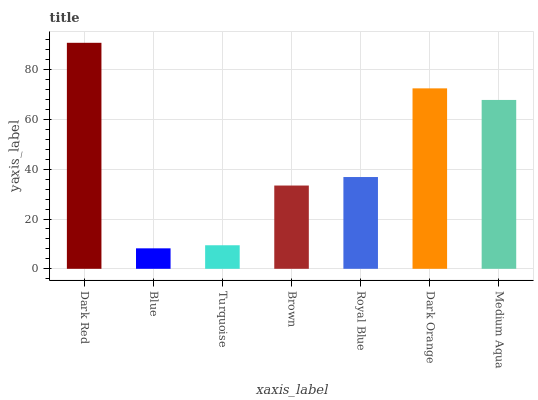Is Blue the minimum?
Answer yes or no. Yes. Is Dark Red the maximum?
Answer yes or no. Yes. Is Turquoise the minimum?
Answer yes or no. No. Is Turquoise the maximum?
Answer yes or no. No. Is Turquoise greater than Blue?
Answer yes or no. Yes. Is Blue less than Turquoise?
Answer yes or no. Yes. Is Blue greater than Turquoise?
Answer yes or no. No. Is Turquoise less than Blue?
Answer yes or no. No. Is Royal Blue the high median?
Answer yes or no. Yes. Is Royal Blue the low median?
Answer yes or no. Yes. Is Turquoise the high median?
Answer yes or no. No. Is Dark Orange the low median?
Answer yes or no. No. 